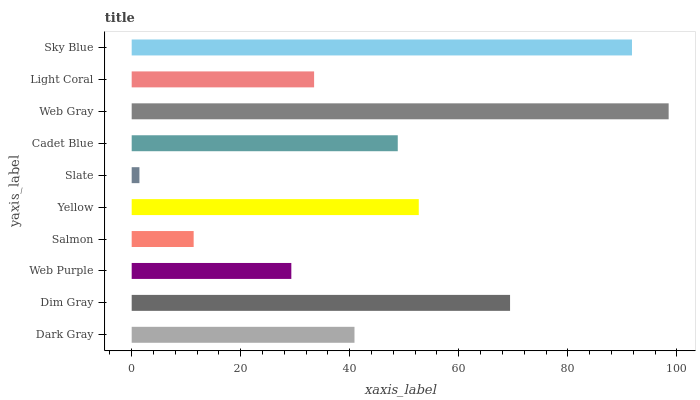Is Slate the minimum?
Answer yes or no. Yes. Is Web Gray the maximum?
Answer yes or no. Yes. Is Dim Gray the minimum?
Answer yes or no. No. Is Dim Gray the maximum?
Answer yes or no. No. Is Dim Gray greater than Dark Gray?
Answer yes or no. Yes. Is Dark Gray less than Dim Gray?
Answer yes or no. Yes. Is Dark Gray greater than Dim Gray?
Answer yes or no. No. Is Dim Gray less than Dark Gray?
Answer yes or no. No. Is Cadet Blue the high median?
Answer yes or no. Yes. Is Dark Gray the low median?
Answer yes or no. Yes. Is Sky Blue the high median?
Answer yes or no. No. Is Sky Blue the low median?
Answer yes or no. No. 